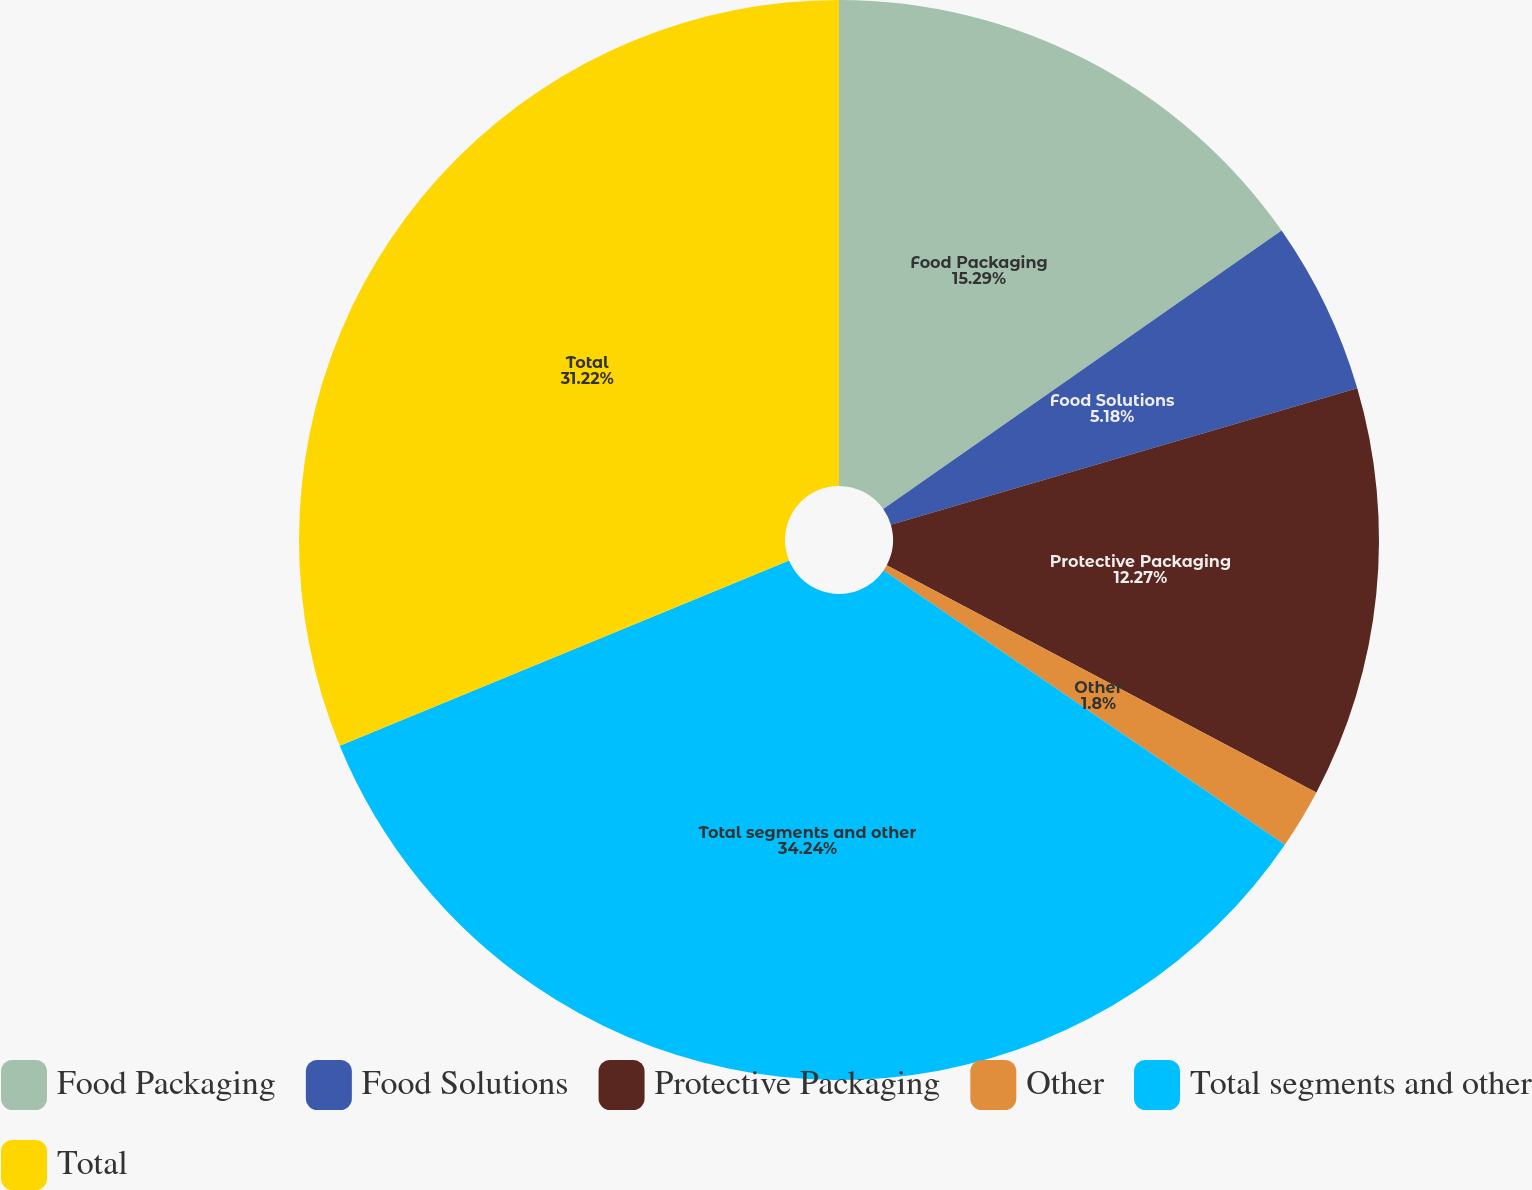Convert chart. <chart><loc_0><loc_0><loc_500><loc_500><pie_chart><fcel>Food Packaging<fcel>Food Solutions<fcel>Protective Packaging<fcel>Other<fcel>Total segments and other<fcel>Total<nl><fcel>15.29%<fcel>5.18%<fcel>12.27%<fcel>1.8%<fcel>34.24%<fcel>31.22%<nl></chart> 